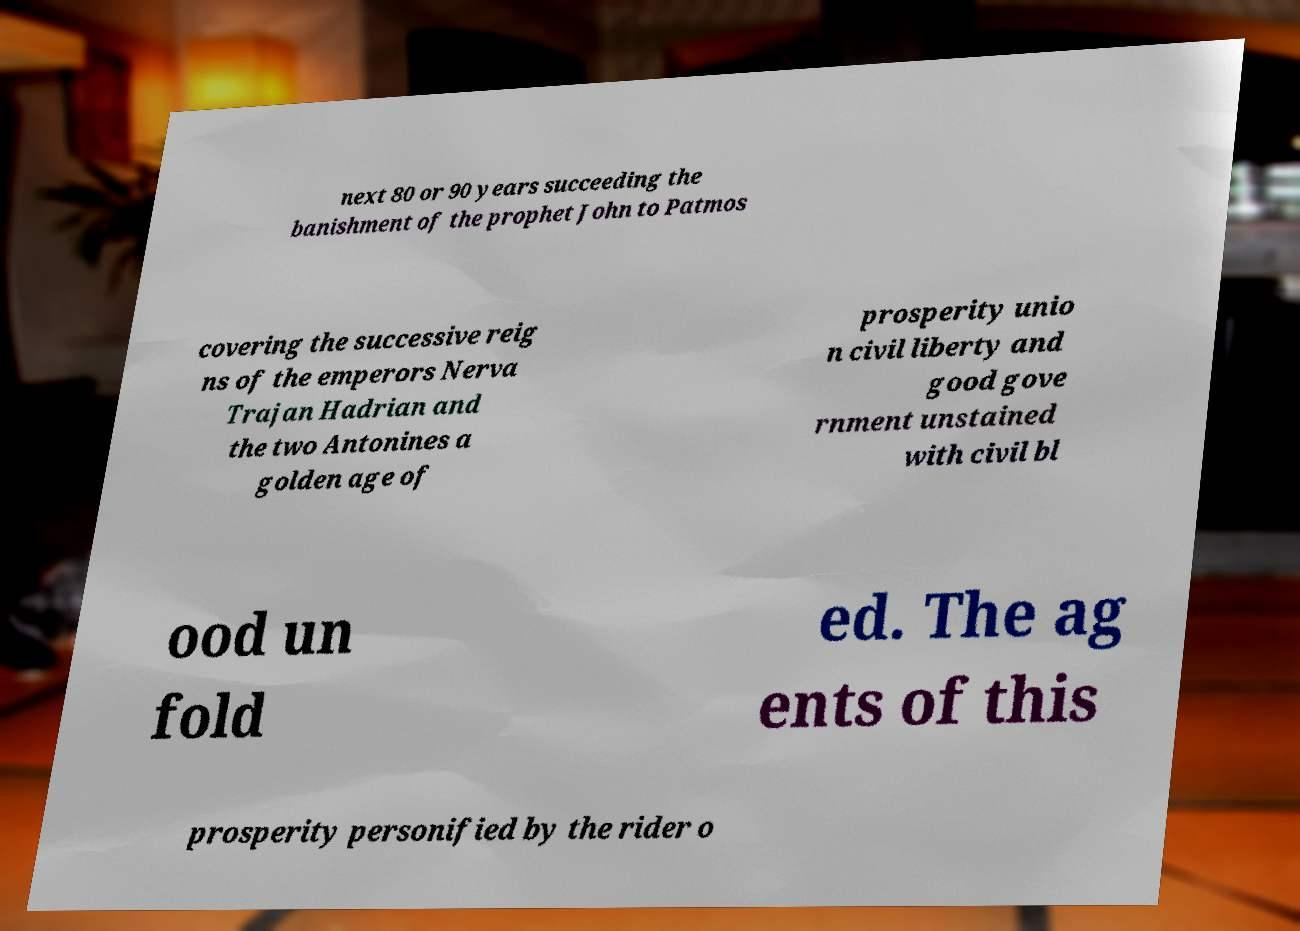There's text embedded in this image that I need extracted. Can you transcribe it verbatim? next 80 or 90 years succeeding the banishment of the prophet John to Patmos covering the successive reig ns of the emperors Nerva Trajan Hadrian and the two Antonines a golden age of prosperity unio n civil liberty and good gove rnment unstained with civil bl ood un fold ed. The ag ents of this prosperity personified by the rider o 